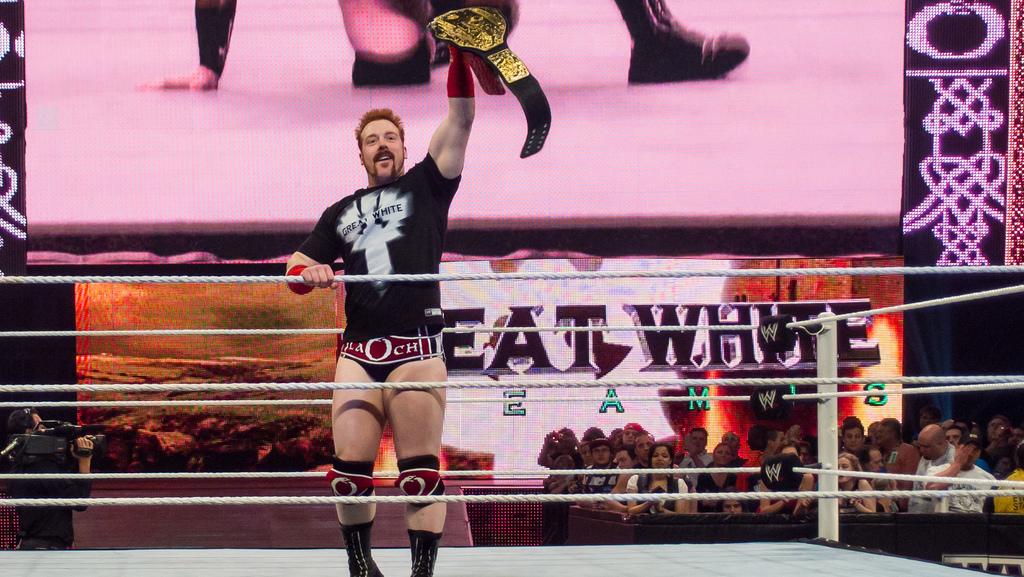What does his shirt say?
Your answer should be very brief. Great white. What is the screen telling us to eat?
Make the answer very short. White. 